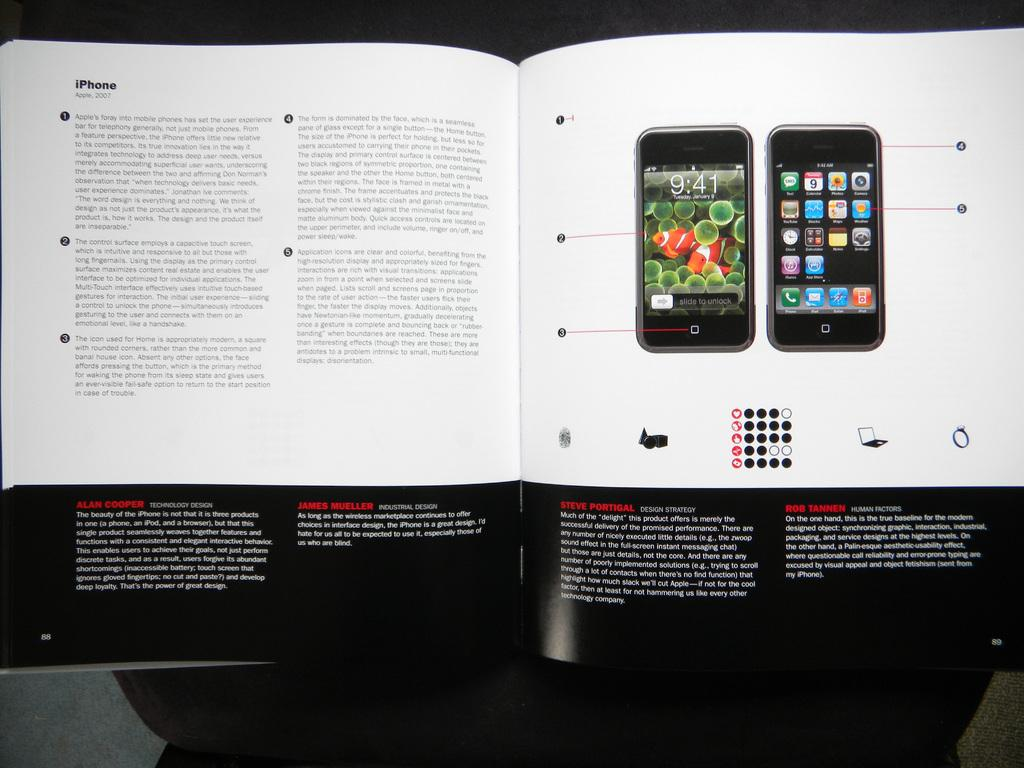<image>
Provide a brief description of the given image. a magazine with an iPhone advertisement inside of it 